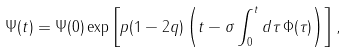Convert formula to latex. <formula><loc_0><loc_0><loc_500><loc_500>\Psi ( t ) = \Psi ( 0 ) \exp \left [ p ( 1 - 2 q ) \left ( t - \sigma \int _ { 0 } ^ { t } d \tau \, \Phi ( \tau ) \right ) \right ] ,</formula> 